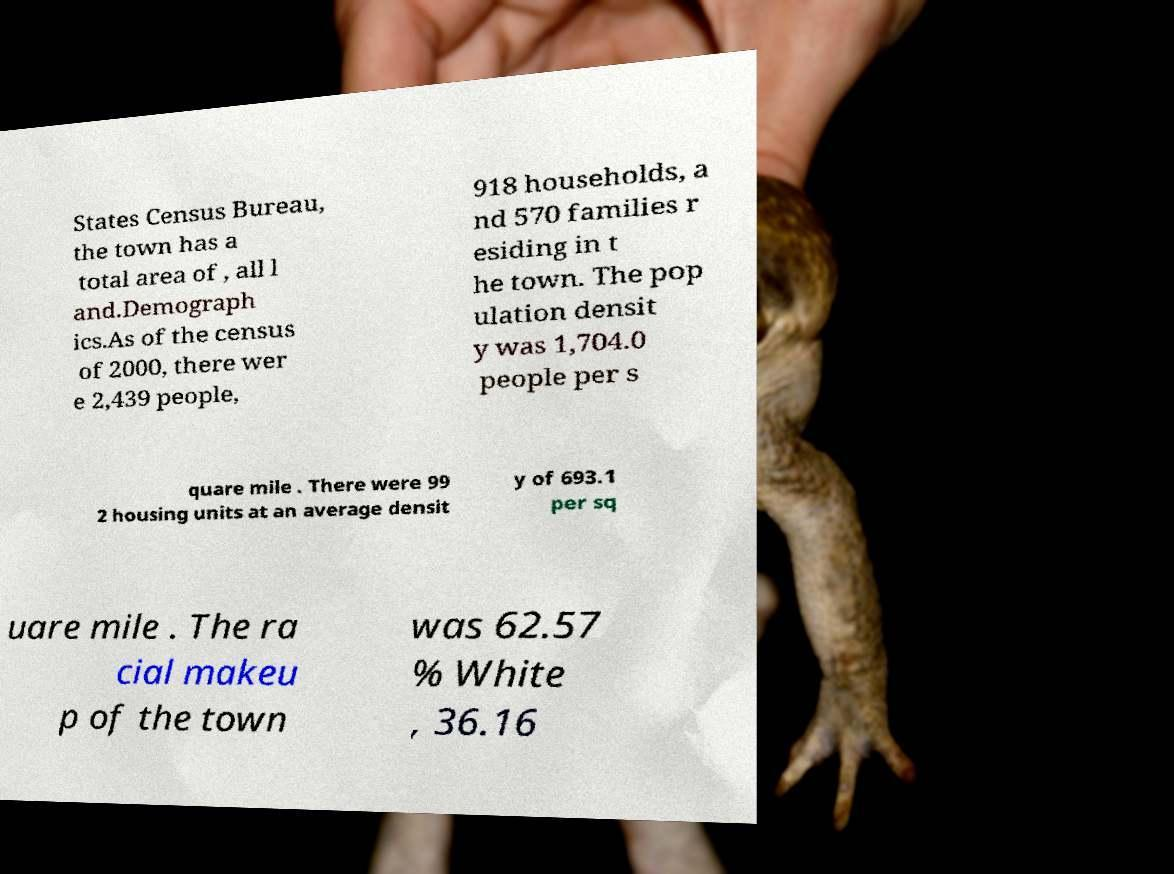Please read and relay the text visible in this image. What does it say? States Census Bureau, the town has a total area of , all l and.Demograph ics.As of the census of 2000, there wer e 2,439 people, 918 households, a nd 570 families r esiding in t he town. The pop ulation densit y was 1,704.0 people per s quare mile . There were 99 2 housing units at an average densit y of 693.1 per sq uare mile . The ra cial makeu p of the town was 62.57 % White , 36.16 